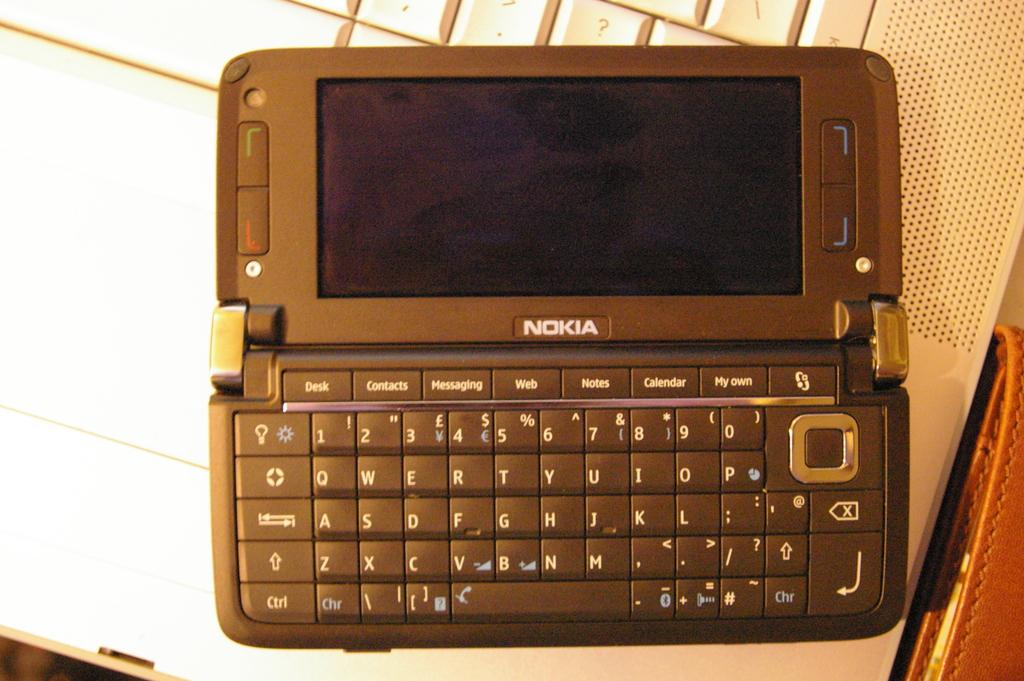What is the name on the desk?
Keep it short and to the point. Unanswerable. Does the nokia have a querty keyboard?
Your answer should be very brief. Yes. 